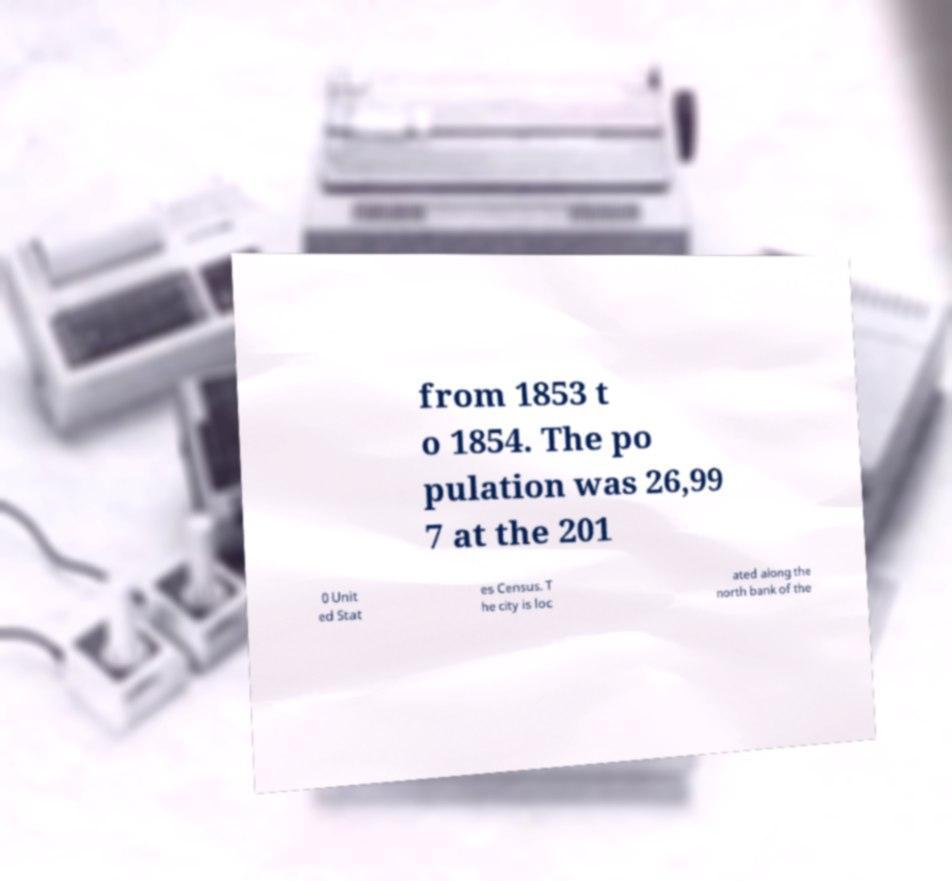For documentation purposes, I need the text within this image transcribed. Could you provide that? from 1853 t o 1854. The po pulation was 26,99 7 at the 201 0 Unit ed Stat es Census. T he city is loc ated along the north bank of the 